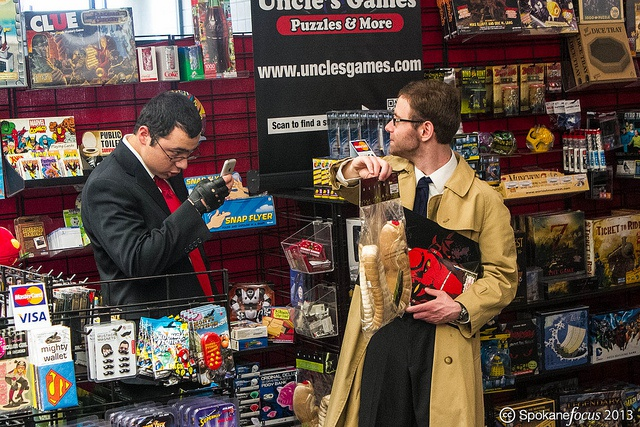Describe the objects in this image and their specific colors. I can see people in tan, black, and maroon tones, people in tan, black, gray, purple, and maroon tones, book in tan, black, olive, maroon, and gray tones, book in tan, black, olive, maroon, and gray tones, and book in tan, ivory, black, and gold tones in this image. 